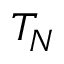<formula> <loc_0><loc_0><loc_500><loc_500>T _ { N }</formula> 